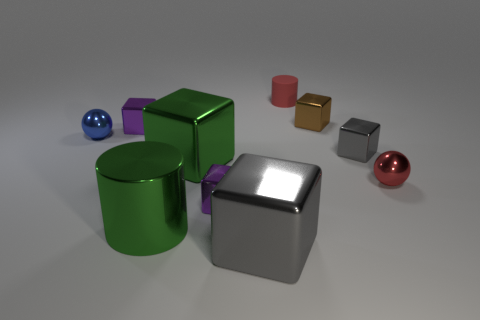Subtract all purple cylinders. Subtract all blue blocks. How many cylinders are left? 2 Subtract all green blocks. How many red balls are left? 1 Subtract all big red metallic objects. Subtract all large green things. How many objects are left? 8 Add 7 brown objects. How many brown objects are left? 8 Add 6 yellow matte things. How many yellow matte things exist? 6 Subtract all green blocks. How many blocks are left? 5 Subtract all small brown cubes. How many cubes are left? 5 Subtract 2 gray cubes. How many objects are left? 8 Subtract all cubes. How many objects are left? 4 Subtract 2 balls. How many balls are left? 0 